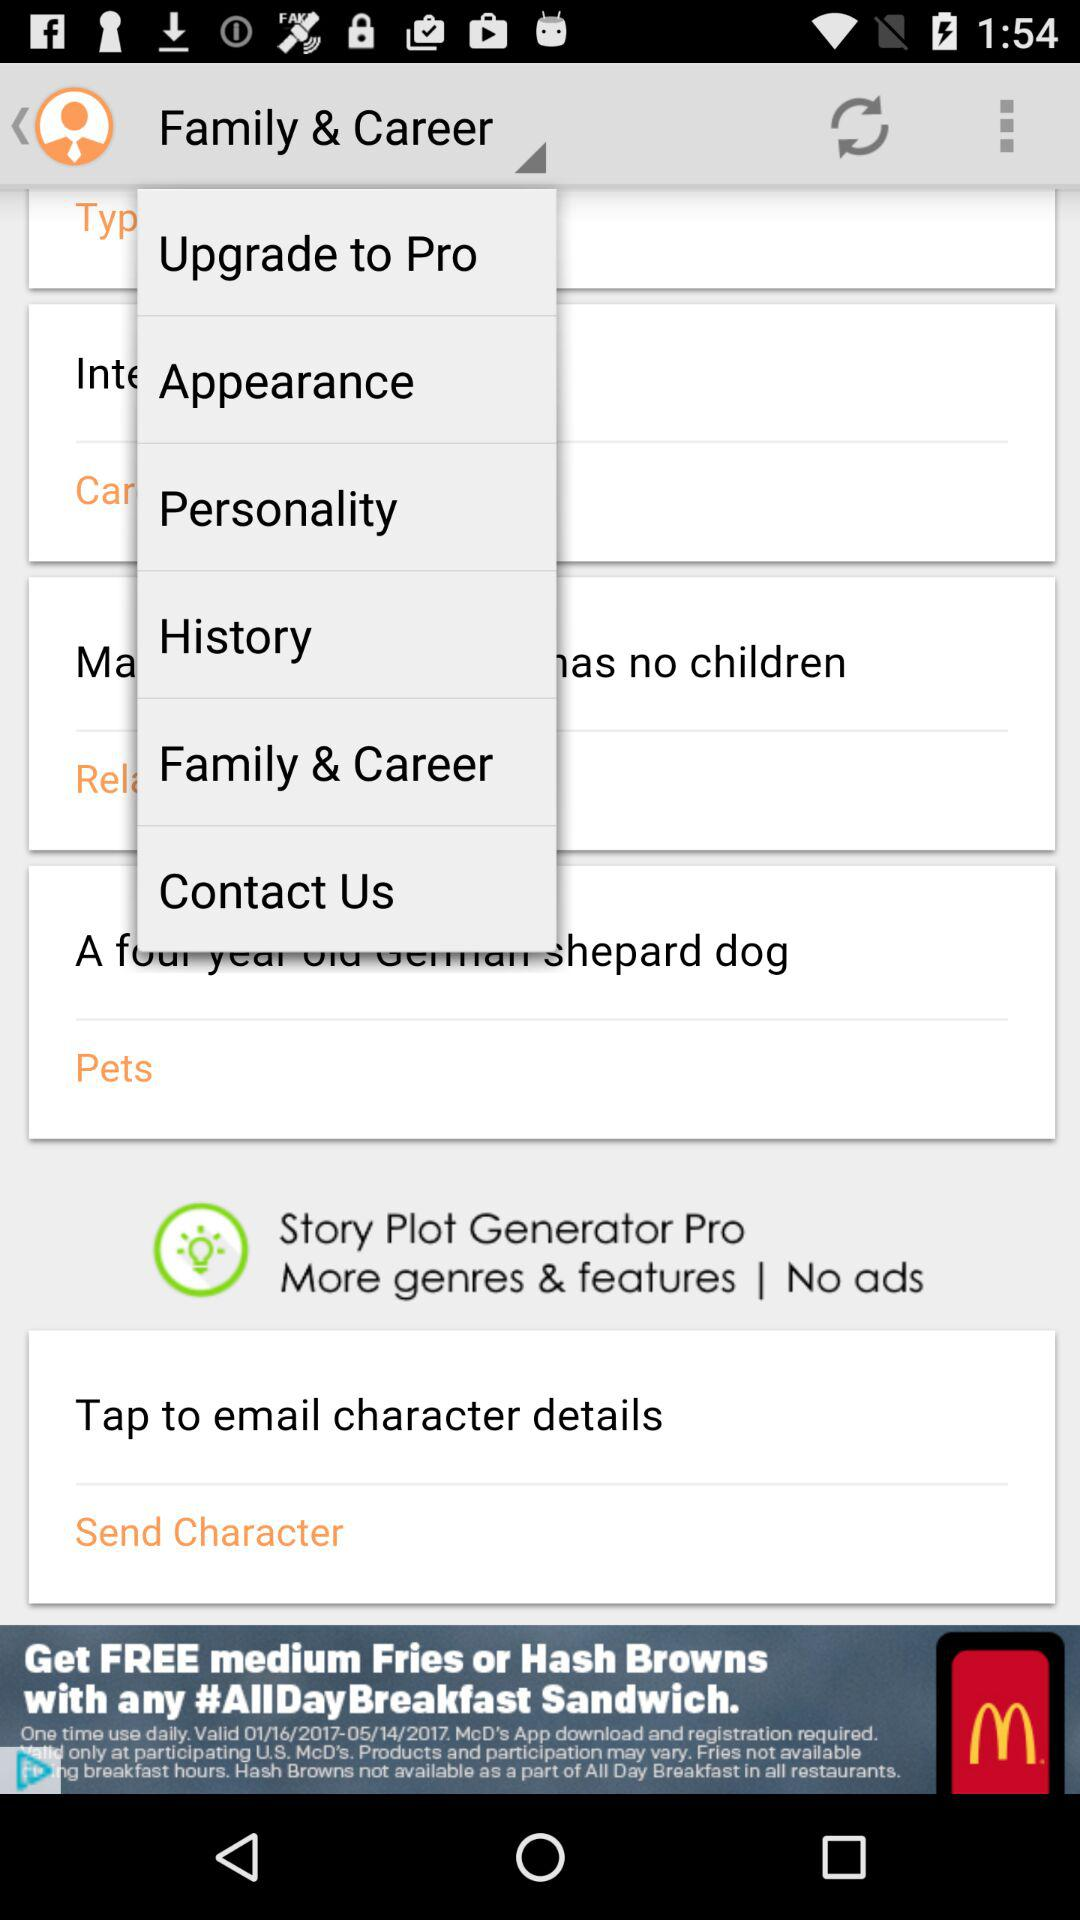What is the name of the application?
When the provided information is insufficient, respond with <no answer>. <no answer> 